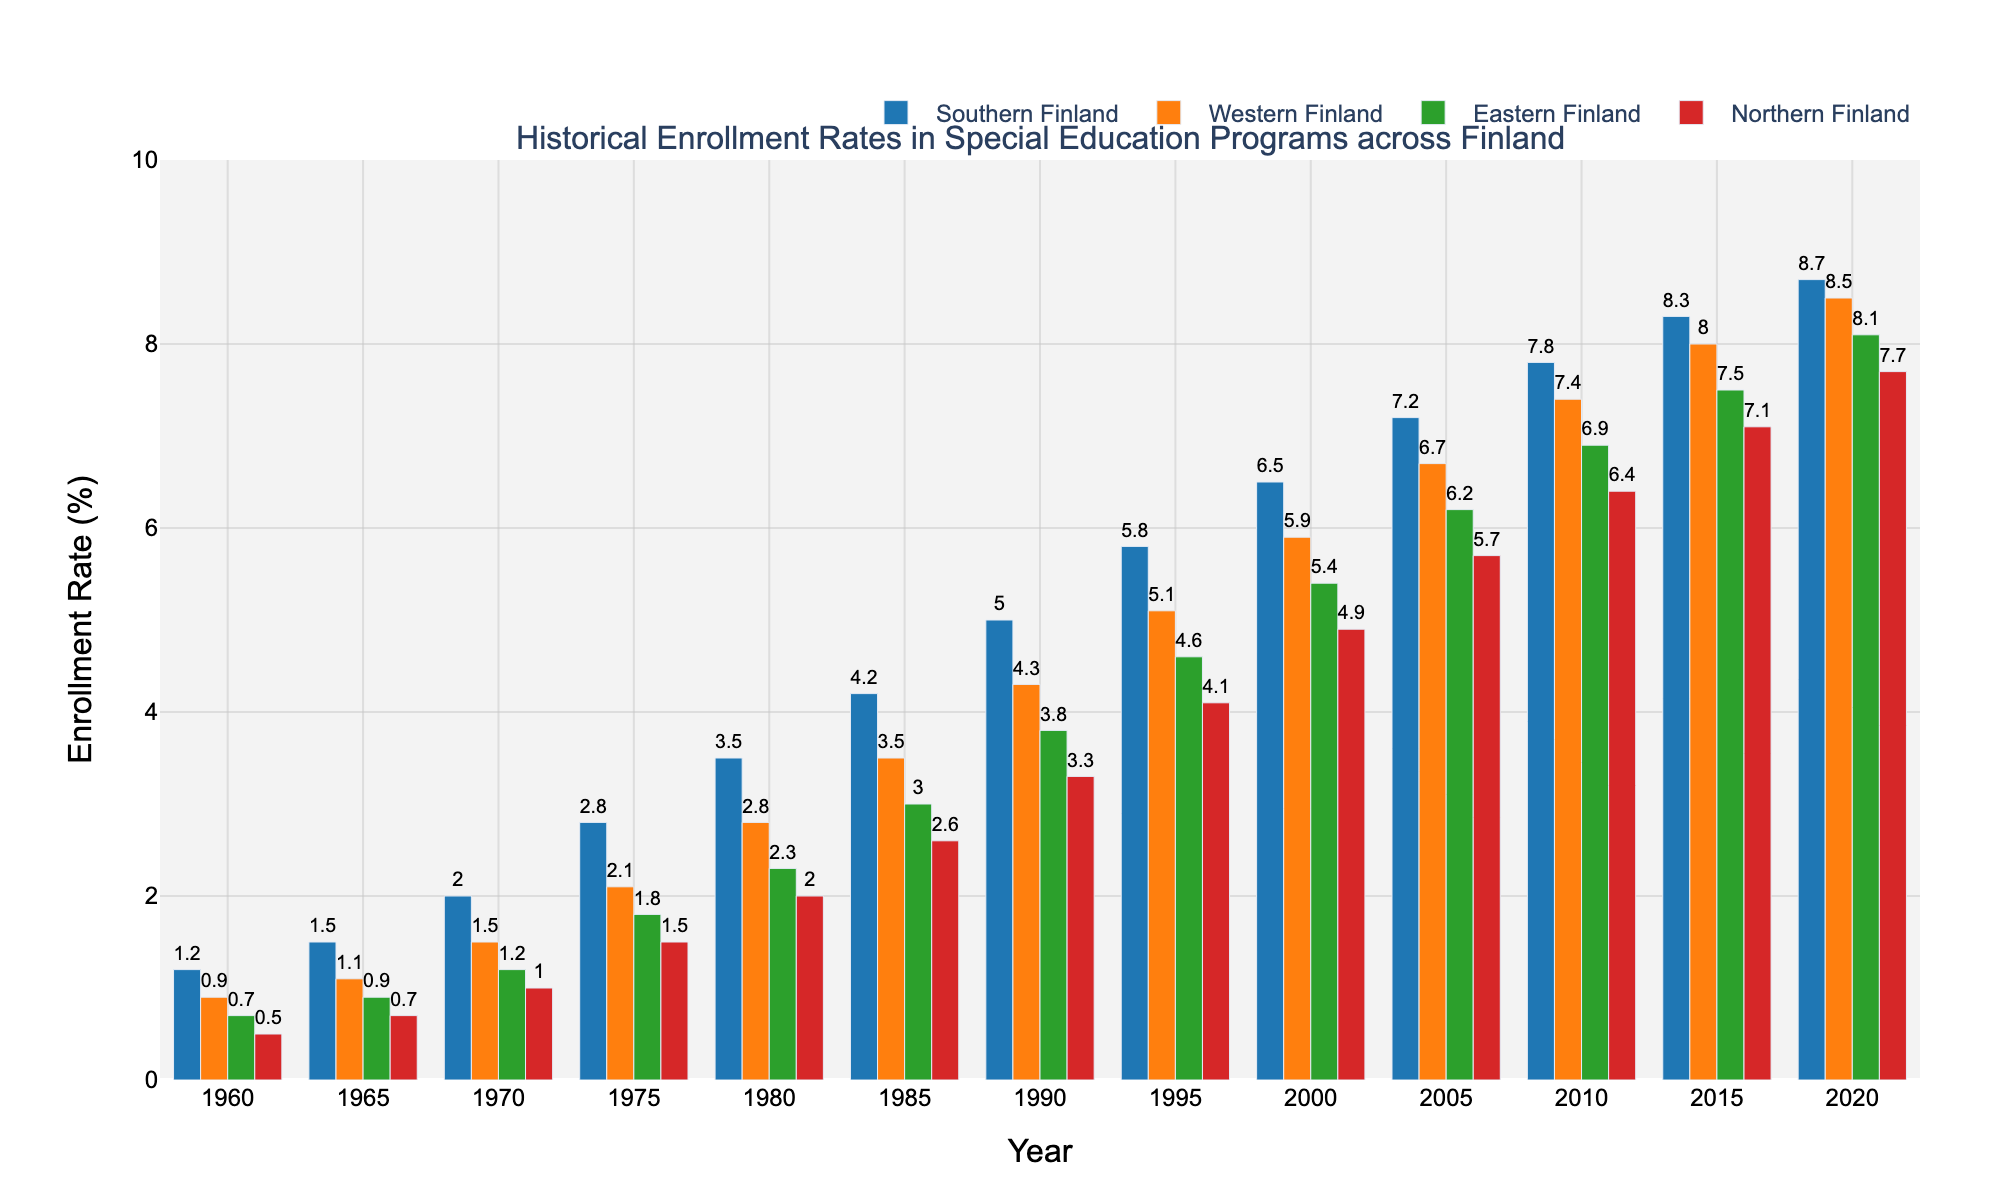What was the enrollment rate trend in Southern Finland from 1960 to 2020? Look at the heights of the bars corresponding to Southern Finland, starting from 1960 to 2020. The heights show a consistent upward trend, increasing from 1.2% in 1960 to 8.7% in 2020.
Answer: Increasing Which region had the lowest enrollment rate in 2015? Compare the heights of the bars for each region at 2015. The bar for Northern Finland is the shortest, indicating the lowest rate.
Answer: Northern Finland By how much did the enrollment rate in Eastern Finland change between 1980 and 2000? To find the change, subtract the 1980 rate (2.3%) from the 2000 rate (5.4%). Calculation: 5.4% - 2.3% = 3.1%.
Answer: 3.1% In which year did Northern Finland's enrollment rate first exceed 2%? Look at the bar heights for Northern Finland until you see a bar that is above 2%. The first year this occurs is 1980.
Answer: 1980 Which two regions had the closest enrollment rates in 2020, and what was the rate difference? Compare the heights of the bars for all regions in 2020. Southern and Western Finland have rates of 8.7% and 8.5%, respectively. The difference is 8.7% - 8.5% = 0.2%.
Answer: Southern Finland and Western Finland, 0.2% What is the overall increase in the enrollment rate for Western Finland from 1960 to 2020? Subtract the 1960 rate (0.9%) from the 2020 rate (8.5%). Calculation: 8.5% - 0.9% = 7.6%.
Answer: 7.6% Which region showed the fastest growth in enrollment rate from 1970 to 1980? Calculate the difference for each region between 1970 and 1980. Southern Finland: 3.5% - 2.0% = 1.5%, Western Finland: 2.8% - 1.5% = 1.3%, Eastern Finland: 2.3% - 1.2% = 1.1%, Northern Finland: 2.0% - 1.0% = 1.0%. Southern Finland has the highest increase.
Answer: Southern Finland Which region had the most consistent growth in enrollment rates from 1960 to 2020? Visually assess the uniformity of the height increments for the bars over the years. Western Finland shows a very steady year-on-year increase.
Answer: Western Finland 